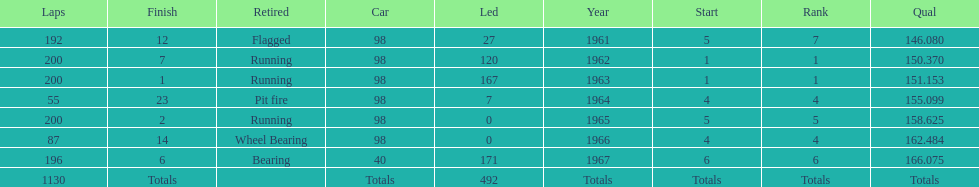What is the most common cause for a retired car? Running. 